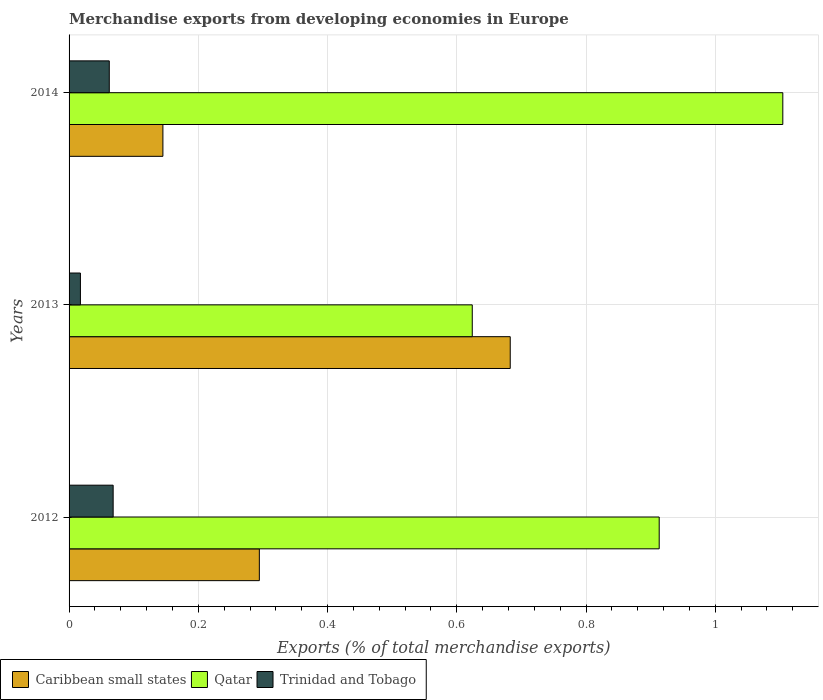Are the number of bars per tick equal to the number of legend labels?
Offer a terse response. Yes. How many bars are there on the 3rd tick from the bottom?
Provide a short and direct response. 3. What is the label of the 1st group of bars from the top?
Keep it short and to the point. 2014. What is the percentage of total merchandise exports in Caribbean small states in 2013?
Offer a very short reply. 0.68. Across all years, what is the maximum percentage of total merchandise exports in Caribbean small states?
Provide a succinct answer. 0.68. Across all years, what is the minimum percentage of total merchandise exports in Qatar?
Make the answer very short. 0.62. In which year was the percentage of total merchandise exports in Trinidad and Tobago minimum?
Give a very brief answer. 2013. What is the total percentage of total merchandise exports in Trinidad and Tobago in the graph?
Your answer should be compact. 0.15. What is the difference between the percentage of total merchandise exports in Qatar in 2013 and that in 2014?
Offer a terse response. -0.48. What is the difference between the percentage of total merchandise exports in Trinidad and Tobago in 2013 and the percentage of total merchandise exports in Caribbean small states in 2012?
Your answer should be compact. -0.28. What is the average percentage of total merchandise exports in Qatar per year?
Your answer should be very brief. 0.88. In the year 2014, what is the difference between the percentage of total merchandise exports in Trinidad and Tobago and percentage of total merchandise exports in Qatar?
Your answer should be very brief. -1.04. In how many years, is the percentage of total merchandise exports in Caribbean small states greater than 1.08 %?
Ensure brevity in your answer.  0. What is the ratio of the percentage of total merchandise exports in Caribbean small states in 2012 to that in 2013?
Provide a short and direct response. 0.43. Is the difference between the percentage of total merchandise exports in Trinidad and Tobago in 2012 and 2013 greater than the difference between the percentage of total merchandise exports in Qatar in 2012 and 2013?
Offer a very short reply. No. What is the difference between the highest and the second highest percentage of total merchandise exports in Caribbean small states?
Make the answer very short. 0.39. What is the difference between the highest and the lowest percentage of total merchandise exports in Trinidad and Tobago?
Your response must be concise. 0.05. In how many years, is the percentage of total merchandise exports in Caribbean small states greater than the average percentage of total merchandise exports in Caribbean small states taken over all years?
Offer a very short reply. 1. What does the 2nd bar from the top in 2012 represents?
Offer a terse response. Qatar. What does the 3rd bar from the bottom in 2014 represents?
Your response must be concise. Trinidad and Tobago. Is it the case that in every year, the sum of the percentage of total merchandise exports in Qatar and percentage of total merchandise exports in Trinidad and Tobago is greater than the percentage of total merchandise exports in Caribbean small states?
Your answer should be compact. No. How many years are there in the graph?
Provide a succinct answer. 3. Are the values on the major ticks of X-axis written in scientific E-notation?
Provide a short and direct response. No. Does the graph contain any zero values?
Your answer should be compact. No. Does the graph contain grids?
Your response must be concise. Yes. What is the title of the graph?
Ensure brevity in your answer.  Merchandise exports from developing economies in Europe. Does "Bulgaria" appear as one of the legend labels in the graph?
Your answer should be compact. No. What is the label or title of the X-axis?
Your response must be concise. Exports (% of total merchandise exports). What is the label or title of the Y-axis?
Offer a very short reply. Years. What is the Exports (% of total merchandise exports) in Caribbean small states in 2012?
Make the answer very short. 0.29. What is the Exports (% of total merchandise exports) of Qatar in 2012?
Your response must be concise. 0.91. What is the Exports (% of total merchandise exports) of Trinidad and Tobago in 2012?
Your answer should be compact. 0.07. What is the Exports (% of total merchandise exports) in Caribbean small states in 2013?
Offer a very short reply. 0.68. What is the Exports (% of total merchandise exports) in Qatar in 2013?
Provide a succinct answer. 0.62. What is the Exports (% of total merchandise exports) of Trinidad and Tobago in 2013?
Give a very brief answer. 0.02. What is the Exports (% of total merchandise exports) of Caribbean small states in 2014?
Provide a short and direct response. 0.15. What is the Exports (% of total merchandise exports) in Qatar in 2014?
Provide a short and direct response. 1.1. What is the Exports (% of total merchandise exports) in Trinidad and Tobago in 2014?
Your response must be concise. 0.06. Across all years, what is the maximum Exports (% of total merchandise exports) in Caribbean small states?
Your answer should be compact. 0.68. Across all years, what is the maximum Exports (% of total merchandise exports) of Qatar?
Provide a succinct answer. 1.1. Across all years, what is the maximum Exports (% of total merchandise exports) in Trinidad and Tobago?
Your answer should be very brief. 0.07. Across all years, what is the minimum Exports (% of total merchandise exports) in Caribbean small states?
Your answer should be very brief. 0.15. Across all years, what is the minimum Exports (% of total merchandise exports) of Qatar?
Ensure brevity in your answer.  0.62. Across all years, what is the minimum Exports (% of total merchandise exports) of Trinidad and Tobago?
Keep it short and to the point. 0.02. What is the total Exports (% of total merchandise exports) in Caribbean small states in the graph?
Your response must be concise. 1.12. What is the total Exports (% of total merchandise exports) in Qatar in the graph?
Your answer should be compact. 2.64. What is the total Exports (% of total merchandise exports) in Trinidad and Tobago in the graph?
Offer a very short reply. 0.15. What is the difference between the Exports (% of total merchandise exports) of Caribbean small states in 2012 and that in 2013?
Ensure brevity in your answer.  -0.39. What is the difference between the Exports (% of total merchandise exports) in Qatar in 2012 and that in 2013?
Make the answer very short. 0.29. What is the difference between the Exports (% of total merchandise exports) in Trinidad and Tobago in 2012 and that in 2013?
Your answer should be compact. 0.05. What is the difference between the Exports (% of total merchandise exports) in Caribbean small states in 2012 and that in 2014?
Ensure brevity in your answer.  0.15. What is the difference between the Exports (% of total merchandise exports) of Qatar in 2012 and that in 2014?
Offer a very short reply. -0.19. What is the difference between the Exports (% of total merchandise exports) in Trinidad and Tobago in 2012 and that in 2014?
Your response must be concise. 0.01. What is the difference between the Exports (% of total merchandise exports) in Caribbean small states in 2013 and that in 2014?
Provide a succinct answer. 0.54. What is the difference between the Exports (% of total merchandise exports) of Qatar in 2013 and that in 2014?
Ensure brevity in your answer.  -0.48. What is the difference between the Exports (% of total merchandise exports) in Trinidad and Tobago in 2013 and that in 2014?
Give a very brief answer. -0.04. What is the difference between the Exports (% of total merchandise exports) of Caribbean small states in 2012 and the Exports (% of total merchandise exports) of Qatar in 2013?
Your response must be concise. -0.33. What is the difference between the Exports (% of total merchandise exports) of Caribbean small states in 2012 and the Exports (% of total merchandise exports) of Trinidad and Tobago in 2013?
Make the answer very short. 0.28. What is the difference between the Exports (% of total merchandise exports) of Qatar in 2012 and the Exports (% of total merchandise exports) of Trinidad and Tobago in 2013?
Ensure brevity in your answer.  0.9. What is the difference between the Exports (% of total merchandise exports) of Caribbean small states in 2012 and the Exports (% of total merchandise exports) of Qatar in 2014?
Make the answer very short. -0.81. What is the difference between the Exports (% of total merchandise exports) of Caribbean small states in 2012 and the Exports (% of total merchandise exports) of Trinidad and Tobago in 2014?
Give a very brief answer. 0.23. What is the difference between the Exports (% of total merchandise exports) of Qatar in 2012 and the Exports (% of total merchandise exports) of Trinidad and Tobago in 2014?
Ensure brevity in your answer.  0.85. What is the difference between the Exports (% of total merchandise exports) in Caribbean small states in 2013 and the Exports (% of total merchandise exports) in Qatar in 2014?
Provide a short and direct response. -0.42. What is the difference between the Exports (% of total merchandise exports) in Caribbean small states in 2013 and the Exports (% of total merchandise exports) in Trinidad and Tobago in 2014?
Your answer should be compact. 0.62. What is the difference between the Exports (% of total merchandise exports) of Qatar in 2013 and the Exports (% of total merchandise exports) of Trinidad and Tobago in 2014?
Ensure brevity in your answer.  0.56. What is the average Exports (% of total merchandise exports) of Caribbean small states per year?
Your answer should be compact. 0.37. What is the average Exports (% of total merchandise exports) of Qatar per year?
Provide a short and direct response. 0.88. What is the average Exports (% of total merchandise exports) in Trinidad and Tobago per year?
Provide a short and direct response. 0.05. In the year 2012, what is the difference between the Exports (% of total merchandise exports) of Caribbean small states and Exports (% of total merchandise exports) of Qatar?
Keep it short and to the point. -0.62. In the year 2012, what is the difference between the Exports (% of total merchandise exports) in Caribbean small states and Exports (% of total merchandise exports) in Trinidad and Tobago?
Your response must be concise. 0.23. In the year 2012, what is the difference between the Exports (% of total merchandise exports) in Qatar and Exports (% of total merchandise exports) in Trinidad and Tobago?
Your answer should be compact. 0.85. In the year 2013, what is the difference between the Exports (% of total merchandise exports) in Caribbean small states and Exports (% of total merchandise exports) in Qatar?
Offer a very short reply. 0.06. In the year 2013, what is the difference between the Exports (% of total merchandise exports) of Caribbean small states and Exports (% of total merchandise exports) of Trinidad and Tobago?
Your answer should be compact. 0.67. In the year 2013, what is the difference between the Exports (% of total merchandise exports) in Qatar and Exports (% of total merchandise exports) in Trinidad and Tobago?
Offer a very short reply. 0.61. In the year 2014, what is the difference between the Exports (% of total merchandise exports) in Caribbean small states and Exports (% of total merchandise exports) in Qatar?
Provide a short and direct response. -0.96. In the year 2014, what is the difference between the Exports (% of total merchandise exports) in Caribbean small states and Exports (% of total merchandise exports) in Trinidad and Tobago?
Give a very brief answer. 0.08. In the year 2014, what is the difference between the Exports (% of total merchandise exports) of Qatar and Exports (% of total merchandise exports) of Trinidad and Tobago?
Your response must be concise. 1.04. What is the ratio of the Exports (% of total merchandise exports) in Caribbean small states in 2012 to that in 2013?
Ensure brevity in your answer.  0.43. What is the ratio of the Exports (% of total merchandise exports) of Qatar in 2012 to that in 2013?
Provide a short and direct response. 1.46. What is the ratio of the Exports (% of total merchandise exports) of Trinidad and Tobago in 2012 to that in 2013?
Give a very brief answer. 3.88. What is the ratio of the Exports (% of total merchandise exports) in Caribbean small states in 2012 to that in 2014?
Offer a terse response. 2.03. What is the ratio of the Exports (% of total merchandise exports) of Qatar in 2012 to that in 2014?
Offer a terse response. 0.83. What is the ratio of the Exports (% of total merchandise exports) in Trinidad and Tobago in 2012 to that in 2014?
Keep it short and to the point. 1.1. What is the ratio of the Exports (% of total merchandise exports) in Caribbean small states in 2013 to that in 2014?
Your answer should be very brief. 4.7. What is the ratio of the Exports (% of total merchandise exports) of Qatar in 2013 to that in 2014?
Provide a succinct answer. 0.56. What is the ratio of the Exports (% of total merchandise exports) of Trinidad and Tobago in 2013 to that in 2014?
Your answer should be very brief. 0.28. What is the difference between the highest and the second highest Exports (% of total merchandise exports) in Caribbean small states?
Provide a short and direct response. 0.39. What is the difference between the highest and the second highest Exports (% of total merchandise exports) in Qatar?
Your answer should be compact. 0.19. What is the difference between the highest and the second highest Exports (% of total merchandise exports) of Trinidad and Tobago?
Your answer should be compact. 0.01. What is the difference between the highest and the lowest Exports (% of total merchandise exports) in Caribbean small states?
Provide a succinct answer. 0.54. What is the difference between the highest and the lowest Exports (% of total merchandise exports) of Qatar?
Provide a short and direct response. 0.48. What is the difference between the highest and the lowest Exports (% of total merchandise exports) in Trinidad and Tobago?
Provide a succinct answer. 0.05. 